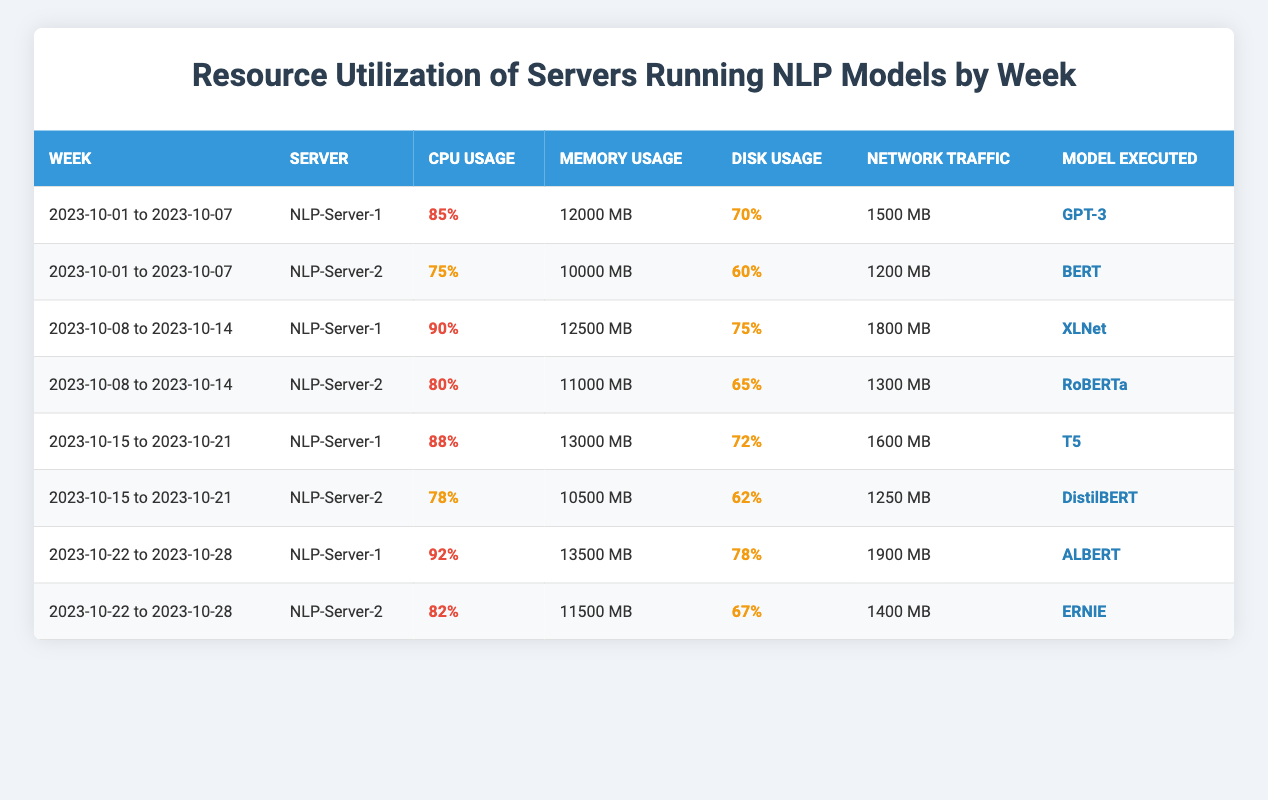What is the CPU usage percentage for NLP-Server-1 in the week of 2023-10-15 to 2023-10-21? Looking at the table, I find the row corresponding to NLP-Server-1 for the week of 2023-10-15 to 2023-10-21, which lists the CPU usage percentage as 88%.
Answer: 88% Which model was run on NLP-Server-2 in the week of 2023-10-08 to 2023-10-14? Referring to the relevant row for NLP-Server-2 in that week, the model executed is indicated as RoBERTa.
Answer: RoBERTa What is the total network traffic in MB for both servers in the week of 2023-10-22 to 2023-10-28? The network traffic for NLP-Server-1 is 1900 MB and for NLP-Server-2 is 1400 MB. Adding these two values gives 1900 + 1400 = 3300 MB.
Answer: 3300 MB Is the disk usage percentage for NLP-Server-1 higher than that for NLP-Server-2 in the week of 2023-10-01 to 2023-10-07? For NLP-Server-1, the disk usage percentage is 70%, while for NLP-Server-2, it is 60%. Since 70% is greater than 60%, the statement is true.
Answer: Yes What was the average memory usage in MB across both servers in the week of 2023-10-15 to 2023-10-21? The memory usage for NLP-Server-1 is 13000 MB and for NLP-Server-2 is 10500 MB. The total memory used is 13000 + 10500 = 23500 MB. Dividing by 2 gives an average of 23500 / 2 = 11750 MB.
Answer: 11750 MB In which week did NLP-Server-1 use the highest CPU percentage? Looking at the CPU usage percentages for NLP-Server-1 across all weeks, I find 90% for the week of 2023-10-08 to 2023-10-14, which is the highest value when compared with values from other weeks.
Answer: 2023-10-08 to 2023-10-14 What is the difference in memory usage in MB between NLP-Server-1 and NLP-Server-2 in the week of 2023-10-22 to 2023-10-28? For NLP-Server-1, the memory usage is 13500 MB and for NLP-Server-2, it is 11500 MB. The difference is calculated as 13500 - 11500 = 2000 MB.
Answer: 2000 MB Was the CPU usage for NLP-Server-2 lower than 80% in any week? Reviewing the CPU usage for NLP-Server-2, it is below 80% in the week of 2023-10-01 to 2023-10-07, where it is 75%. Therefore, the answer is true.
Answer: Yes Which server had the highest disk usage percentage across all weeks? Checking the disk usage percentages, NLP-Server-1 has 78% in the week of 2023-10-22 to 2023-10-28, which is the highest when compared to all percentages for both servers.
Answer: NLP-Server-1 For the week of 2023-10-01 to 2023-10-07, what percentage of CPU usage did NLP-Server-2 have compared to NLP-Server-1? NLP-Server-2 had a CPU usage of 75%, while NLP-Server-1 had 85%. To find the comparison percentage, calculate (75 / 85) * 100 = 88.24%, which means NLP-Server-2 utilized about 88.24% of the CPU usage of NLP-Server-1.
Answer: 88.24% 